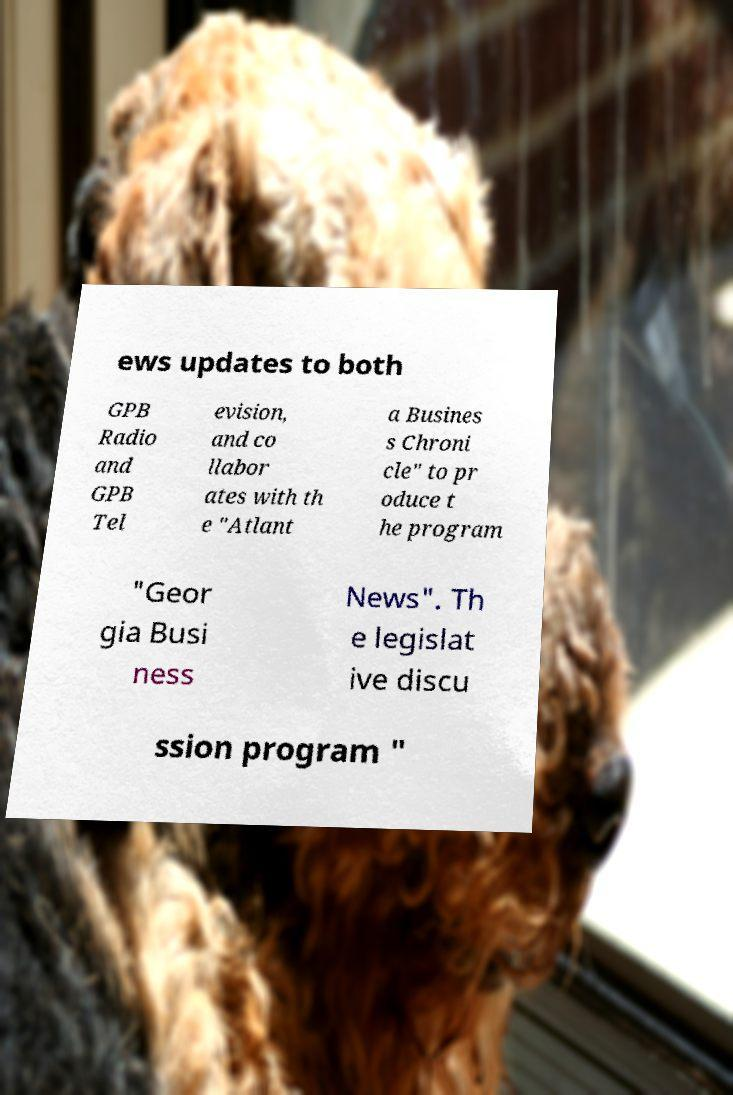Can you read and provide the text displayed in the image?This photo seems to have some interesting text. Can you extract and type it out for me? ews updates to both GPB Radio and GPB Tel evision, and co llabor ates with th e "Atlant a Busines s Chroni cle" to pr oduce t he program "Geor gia Busi ness News". Th e legislat ive discu ssion program " 